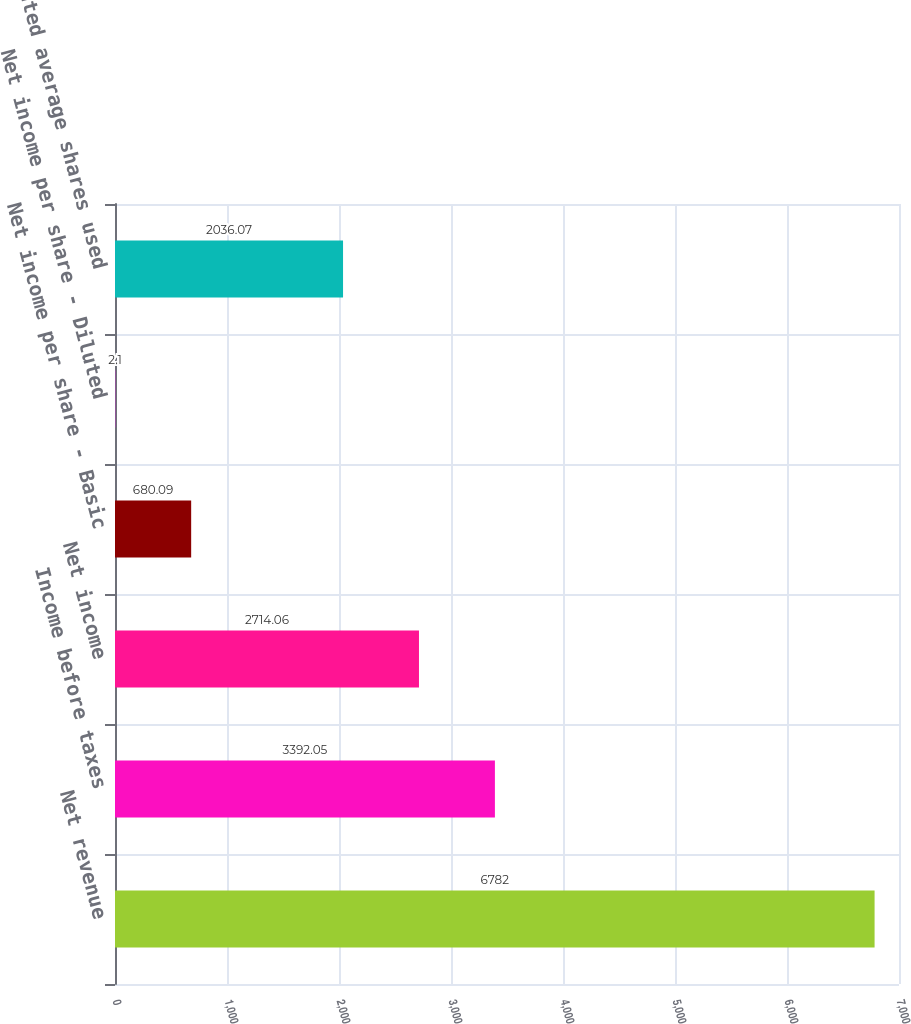Convert chart to OTSL. <chart><loc_0><loc_0><loc_500><loc_500><bar_chart><fcel>Net revenue<fcel>Income before taxes<fcel>Net income<fcel>Net income per share - Basic<fcel>Net income per share - Diluted<fcel>Weighted average shares used<nl><fcel>6782<fcel>3392.05<fcel>2714.06<fcel>680.09<fcel>2.1<fcel>2036.07<nl></chart> 